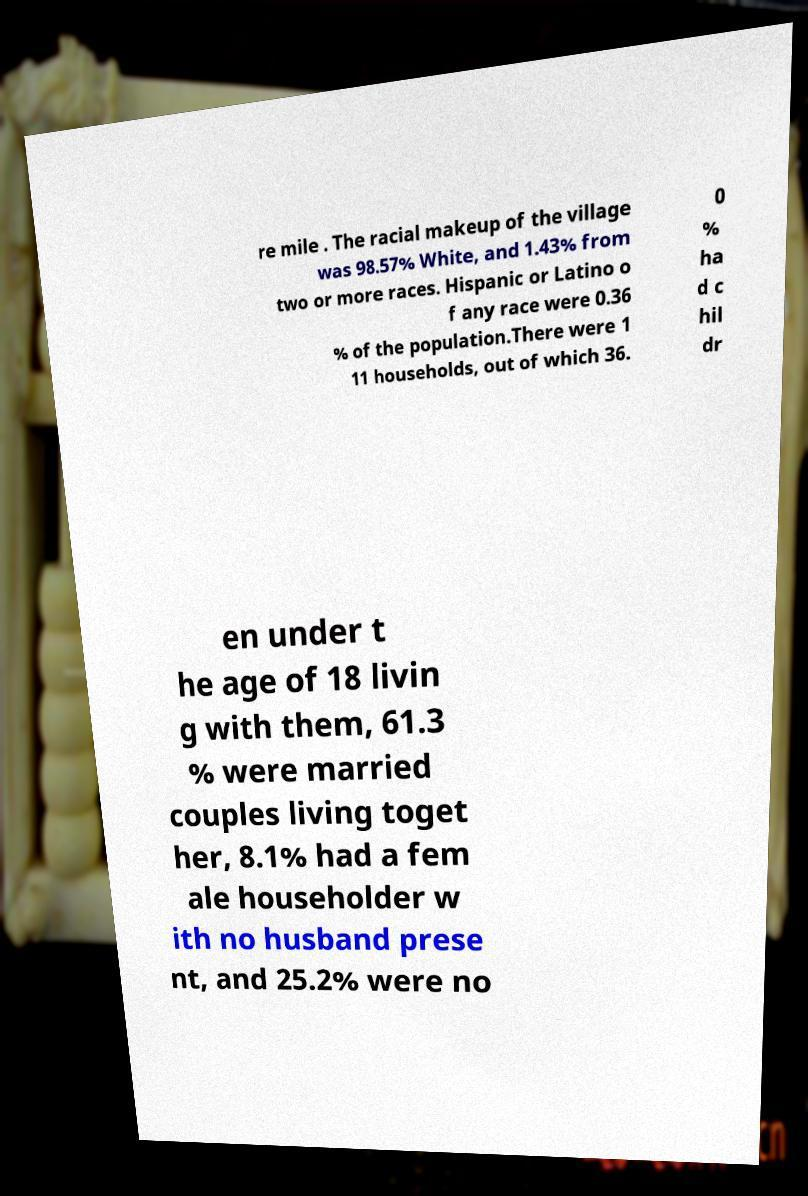Please identify and transcribe the text found in this image. re mile . The racial makeup of the village was 98.57% White, and 1.43% from two or more races. Hispanic or Latino o f any race were 0.36 % of the population.There were 1 11 households, out of which 36. 0 % ha d c hil dr en under t he age of 18 livin g with them, 61.3 % were married couples living toget her, 8.1% had a fem ale householder w ith no husband prese nt, and 25.2% were no 